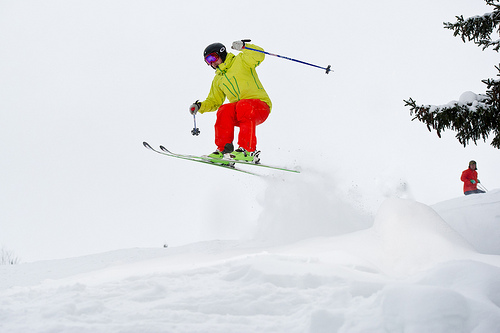Please provide a short description for this region: [0.44, 0.21, 0.69, 0.51]. Pole parallel with ski. Please provide the bounding box coordinate of the region this sentence describes: a tree on the side of the hill. [0.78, 0.18, 1.0, 0.46] Please provide the bounding box coordinate of the region this sentence describes: black helmet on head. [0.41, 0.24, 0.46, 0.28] Please provide the bounding box coordinate of the region this sentence describes: yellow jacket on skier. [0.4, 0.25, 0.55, 0.39] Please provide the bounding box coordinate of the region this sentence describes: neon orange ski pants. [0.41, 0.36, 0.58, 0.49] Please provide a short description for this region: [0.88, 0.47, 0.99, 0.59]. A skier in a red jacket and balck hat. Please provide a short description for this region: [0.38, 0.26, 0.45, 0.3]. The goggles on the man's head. Please provide the bounding box coordinate of the region this sentence describes: a ski pole the man is holding. [0.44, 0.23, 0.7, 0.34] Please provide the bounding box coordinate of the region this sentence describes: snow is on the tree. [0.82, 0.34, 0.98, 0.45] Please provide a short description for this region: [0.33, 0.35, 0.58, 0.51]. Bent legs in orange pants. 